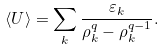Convert formula to latex. <formula><loc_0><loc_0><loc_500><loc_500>\langle U \rangle = \sum _ { k } \frac { \varepsilon _ { k } } { \rho _ { k } ^ { q } - \rho _ { k } ^ { q - 1 } } .</formula> 